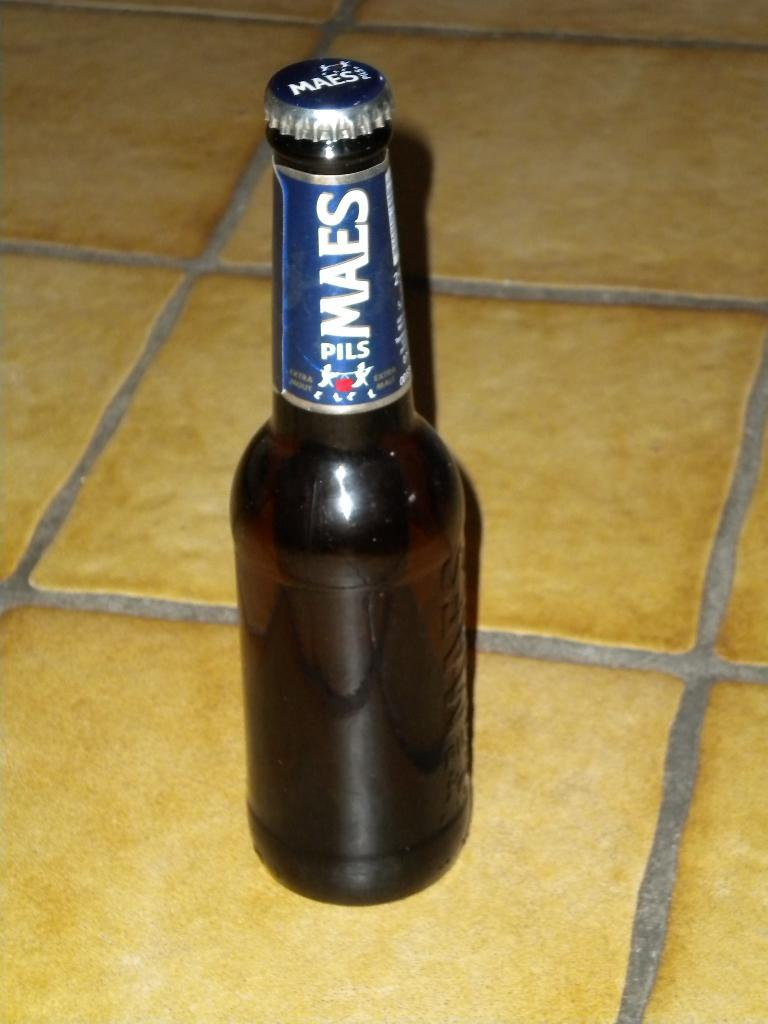What type of floor is visible in the image? There is a floor with a tile in the image. What object is placed on the floor? There is a brown bottle on the floor. What can be seen on the bottle? The bottle has a label on it. What is written on the label? The label has the name "MAES pils" on it. What type of toothbrush is used by the judge in the image? There is no judge or toothbrush present in the image. 